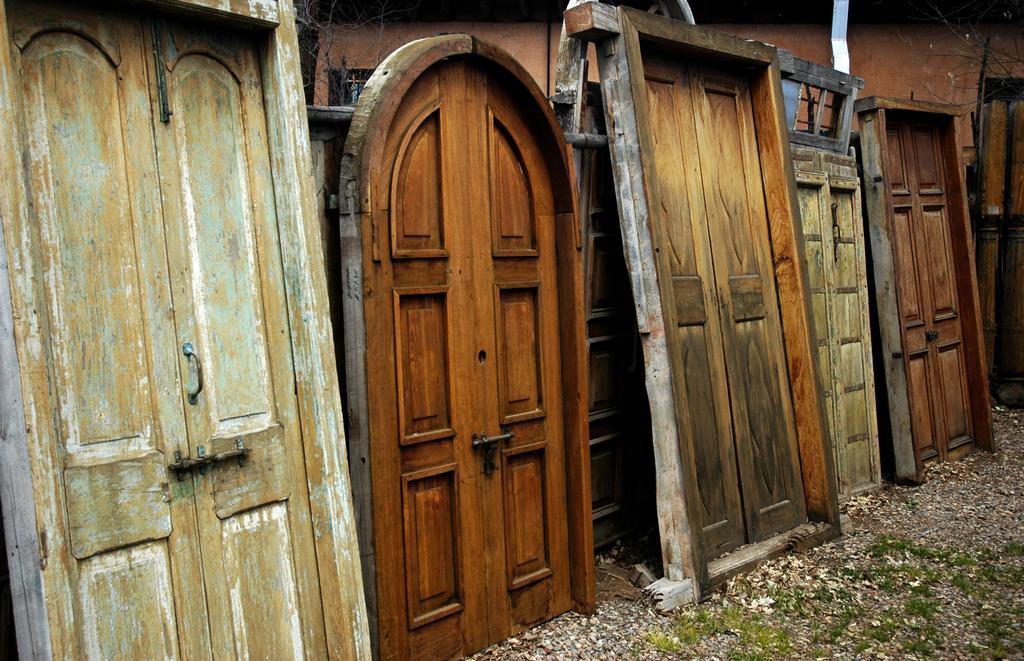Describe this image in one or two sentences. In this image I can see doors. On the right bottom of the image there is a grass. In the background of the image I can see a wall and branches.   